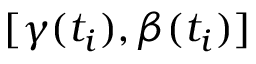Convert formula to latex. <formula><loc_0><loc_0><loc_500><loc_500>[ \gamma ( t _ { i } ) , \beta ( t _ { i } ) ]</formula> 